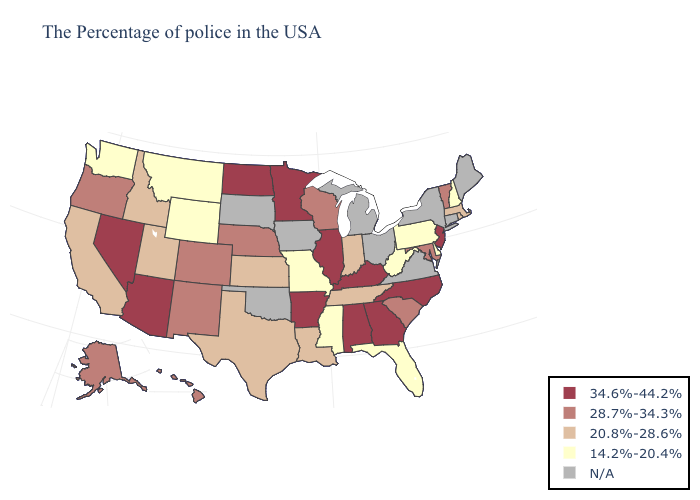Does the first symbol in the legend represent the smallest category?
Concise answer only. No. What is the value of Alabama?
Short answer required. 34.6%-44.2%. What is the highest value in the South ?
Write a very short answer. 34.6%-44.2%. Does Arkansas have the lowest value in the South?
Keep it brief. No. What is the lowest value in states that border Ohio?
Answer briefly. 14.2%-20.4%. Does the map have missing data?
Quick response, please. Yes. Does Arizona have the highest value in the USA?
Keep it brief. Yes. Name the states that have a value in the range 14.2%-20.4%?
Give a very brief answer. New Hampshire, Delaware, Pennsylvania, West Virginia, Florida, Mississippi, Missouri, Wyoming, Montana, Washington. What is the value of Indiana?
Concise answer only. 20.8%-28.6%. What is the value of Florida?
Short answer required. 14.2%-20.4%. What is the highest value in the USA?
Keep it brief. 34.6%-44.2%. What is the value of Mississippi?
Keep it brief. 14.2%-20.4%. Does Wisconsin have the highest value in the USA?
Answer briefly. No. Which states hav the highest value in the South?
Short answer required. North Carolina, Georgia, Kentucky, Alabama, Arkansas. 